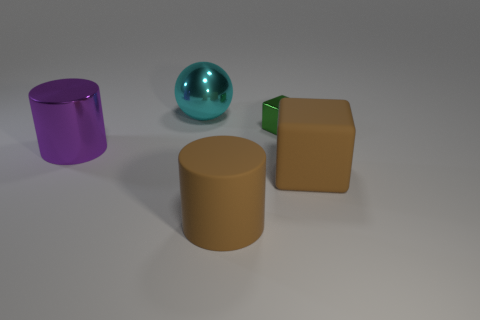How big is the metallic thing that is to the right of the big cylinder in front of the brown thing that is to the right of the tiny metal thing?
Make the answer very short. Small. What shape is the thing that is behind the rubber cube and in front of the small green thing?
Offer a very short reply. Cylinder. Are there the same number of large brown rubber things that are right of the tiny green metallic thing and cubes left of the big brown rubber block?
Make the answer very short. Yes. Are there any big spheres that have the same material as the small object?
Your answer should be compact. Yes. Does the big brown thing left of the tiny green metal block have the same material as the tiny object?
Provide a short and direct response. No. What is the size of the object that is in front of the cyan ball and behind the big purple metal thing?
Make the answer very short. Small. The metal ball has what color?
Provide a succinct answer. Cyan. How many big yellow rubber spheres are there?
Your answer should be very brief. 0. What number of other blocks have the same color as the matte block?
Give a very brief answer. 0. Does the brown thing that is in front of the big brown matte block have the same shape as the shiny thing in front of the small shiny cube?
Make the answer very short. Yes. 